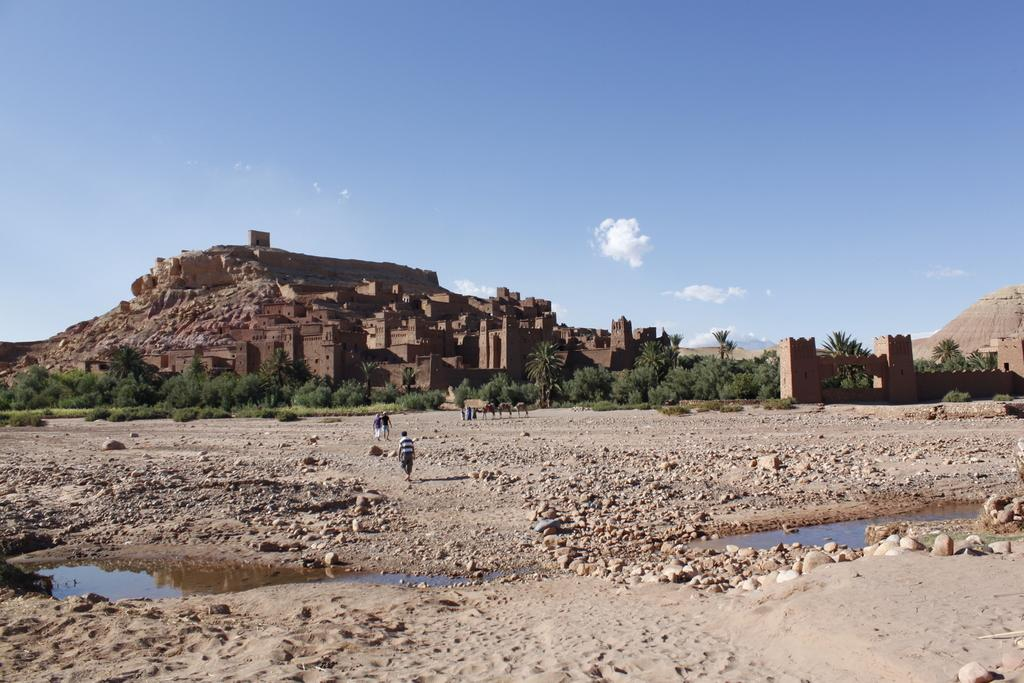What type of structure is in the image? There is a fort in the image. What is in front of the fort? There are trees in front of the fort. What type of terrain is visible in the image? There is land visible in the image. What else can be seen in the image besides the fort and trees? There is water visible in the image. What are the people in the image doing? There are people walking in front of the fort. What is visible at the top of the image? The sky is visible at the top of the image. Can you see any lines on the owl in the image? There is no owl present in the image, so it is not possible to see any lines on it. 